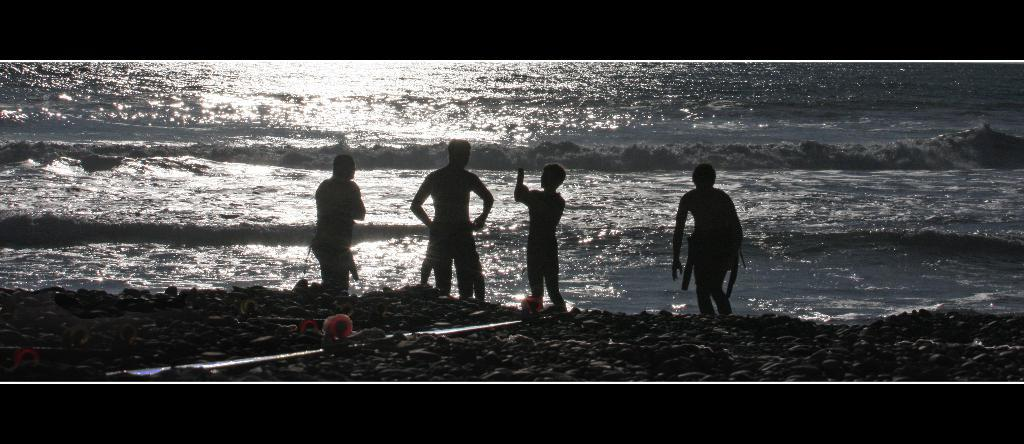What type of objects can be seen in the front of the image? There are stones in the front of the image. What is happening in the center of the image? There are persons standing in the center of the image. What can be seen in the background of the image? There is water visible in the background of the image. Where is the school located in the image? There is no school present in the image. What type of tray can be seen being carried by one of the persons in the image? There is no tray visible in the image; only stones, persons, and water are present. 